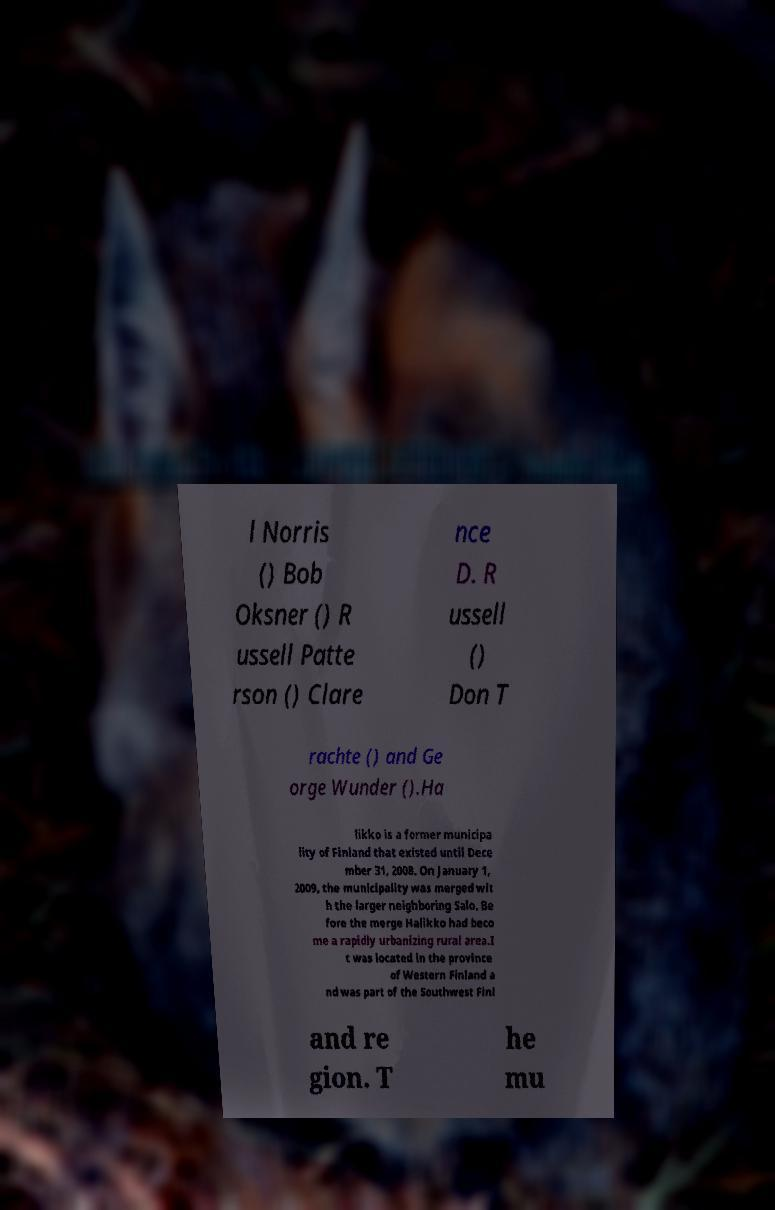Please identify and transcribe the text found in this image. l Norris () Bob Oksner () R ussell Patte rson () Clare nce D. R ussell () Don T rachte () and Ge orge Wunder ().Ha likko is a former municipa lity of Finland that existed until Dece mber 31, 2008. On January 1, 2009, the municipality was merged wit h the larger neighboring Salo. Be fore the merge Halikko had beco me a rapidly urbanizing rural area.I t was located in the province of Western Finland a nd was part of the Southwest Finl and re gion. T he mu 